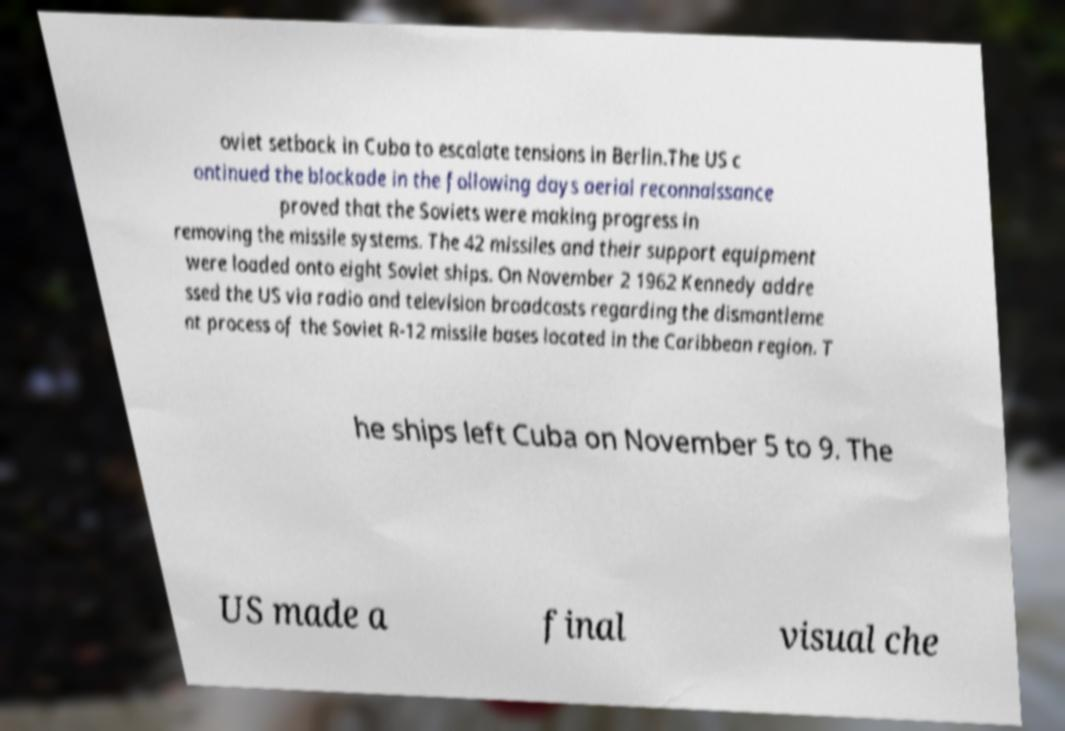Can you read and provide the text displayed in the image?This photo seems to have some interesting text. Can you extract and type it out for me? oviet setback in Cuba to escalate tensions in Berlin.The US c ontinued the blockade in the following days aerial reconnaissance proved that the Soviets were making progress in removing the missile systems. The 42 missiles and their support equipment were loaded onto eight Soviet ships. On November 2 1962 Kennedy addre ssed the US via radio and television broadcasts regarding the dismantleme nt process of the Soviet R-12 missile bases located in the Caribbean region. T he ships left Cuba on November 5 to 9. The US made a final visual che 